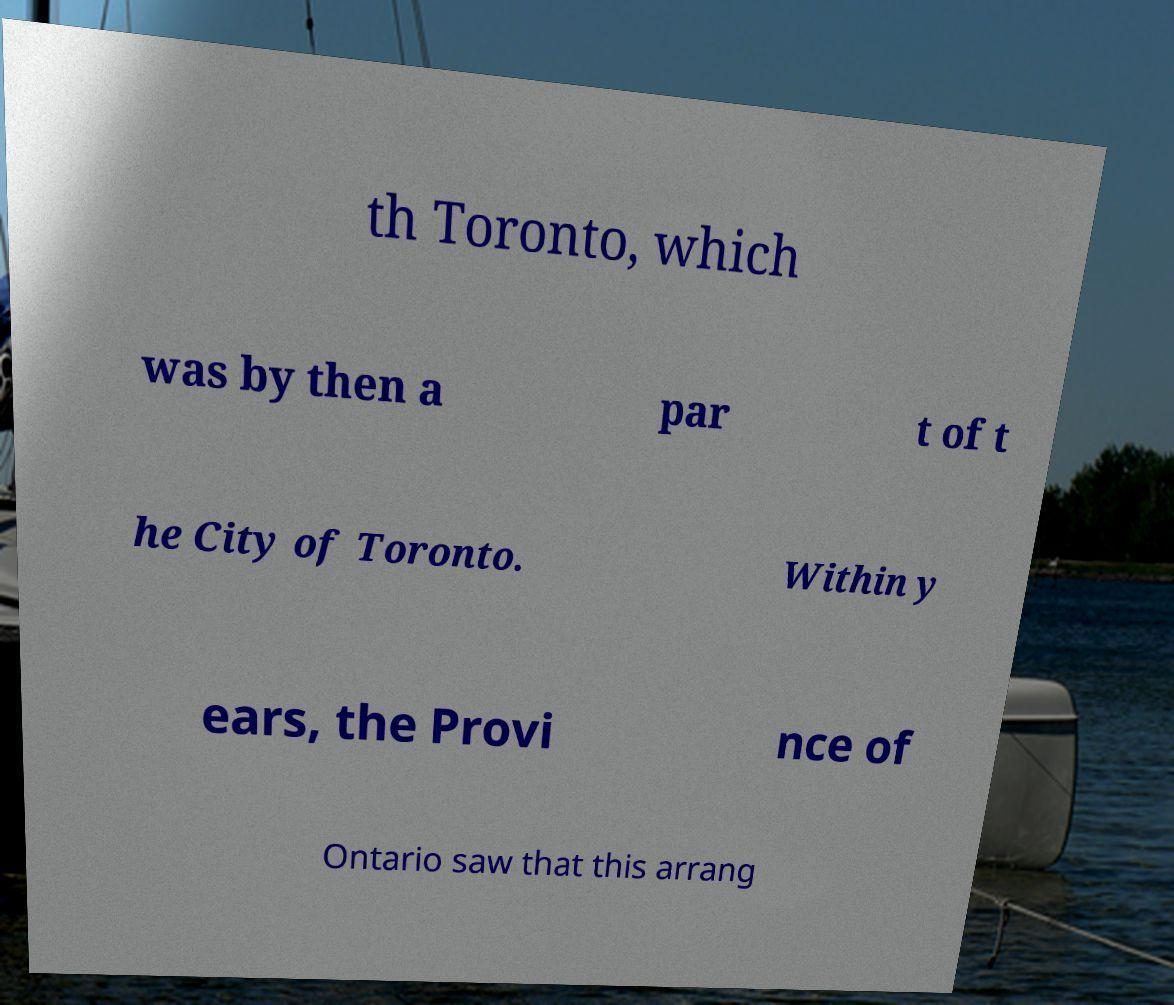Could you extract and type out the text from this image? th Toronto, which was by then a par t of t he City of Toronto. Within y ears, the Provi nce of Ontario saw that this arrang 